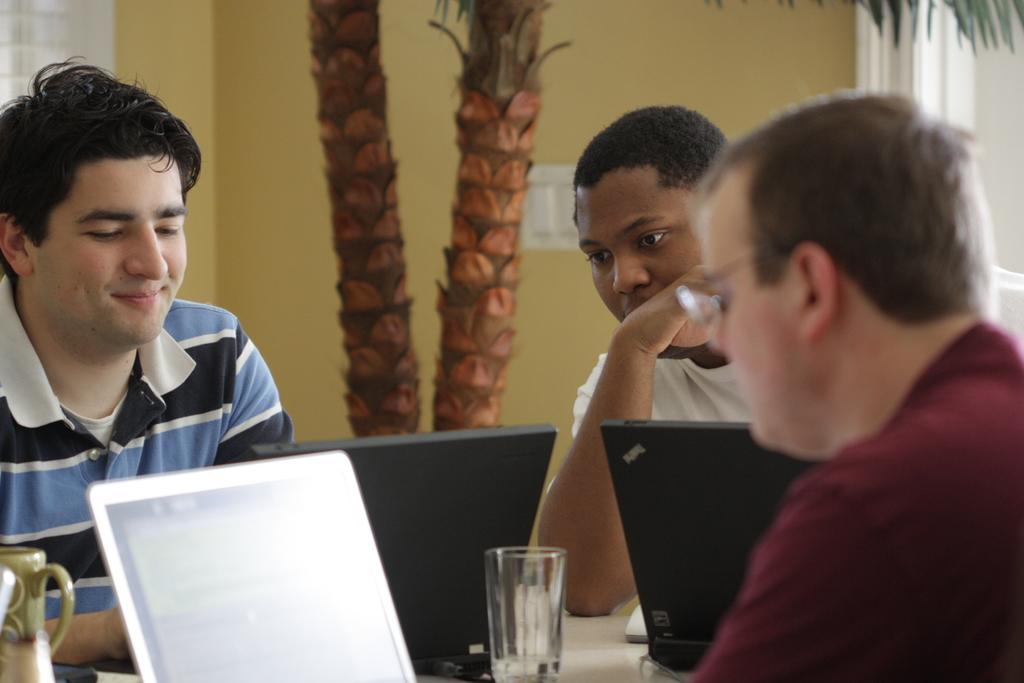Could you give a brief overview of what you see in this image? This picture shows few people seated and we see laptops and a glass on the table and we see trees and a house. 